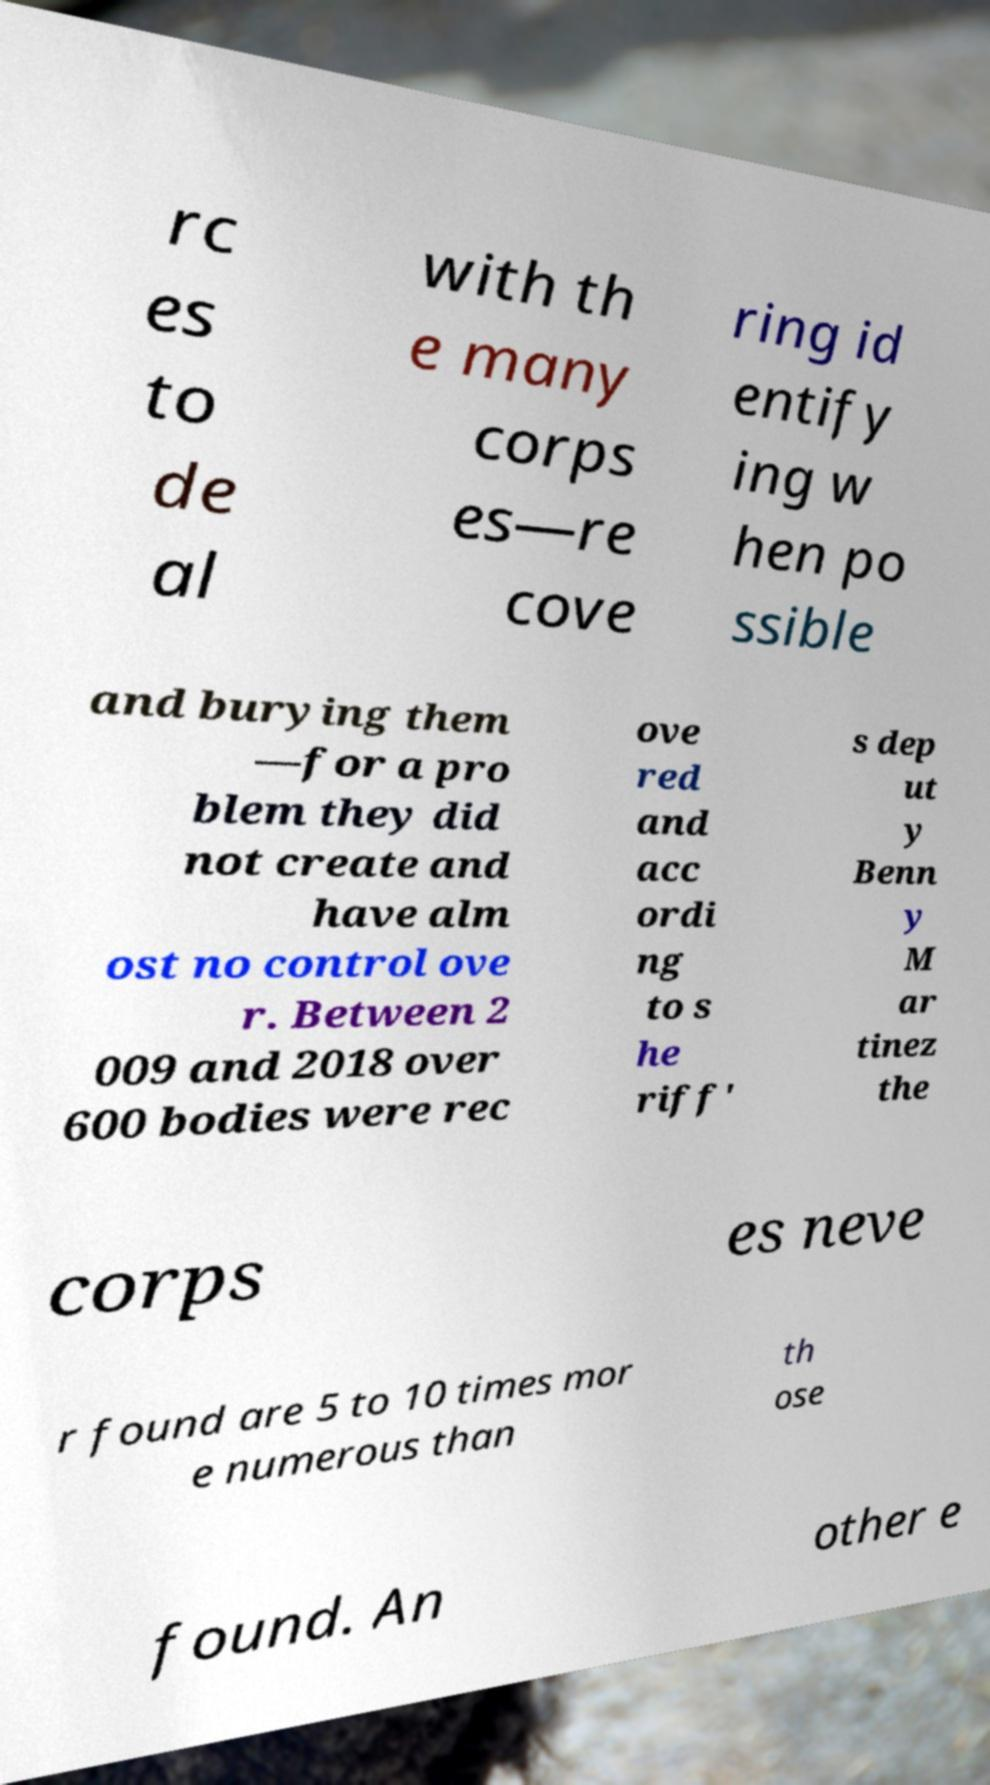Could you extract and type out the text from this image? rc es to de al with th e many corps es—re cove ring id entify ing w hen po ssible and burying them —for a pro blem they did not create and have alm ost no control ove r. Between 2 009 and 2018 over 600 bodies were rec ove red and acc ordi ng to s he riff' s dep ut y Benn y M ar tinez the corps es neve r found are 5 to 10 times mor e numerous than th ose found. An other e 